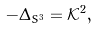Convert formula to latex. <formula><loc_0><loc_0><loc_500><loc_500>- \Delta _ { S ^ { 3 } } = { \mathcal { K } } ^ { 2 } ,</formula> 